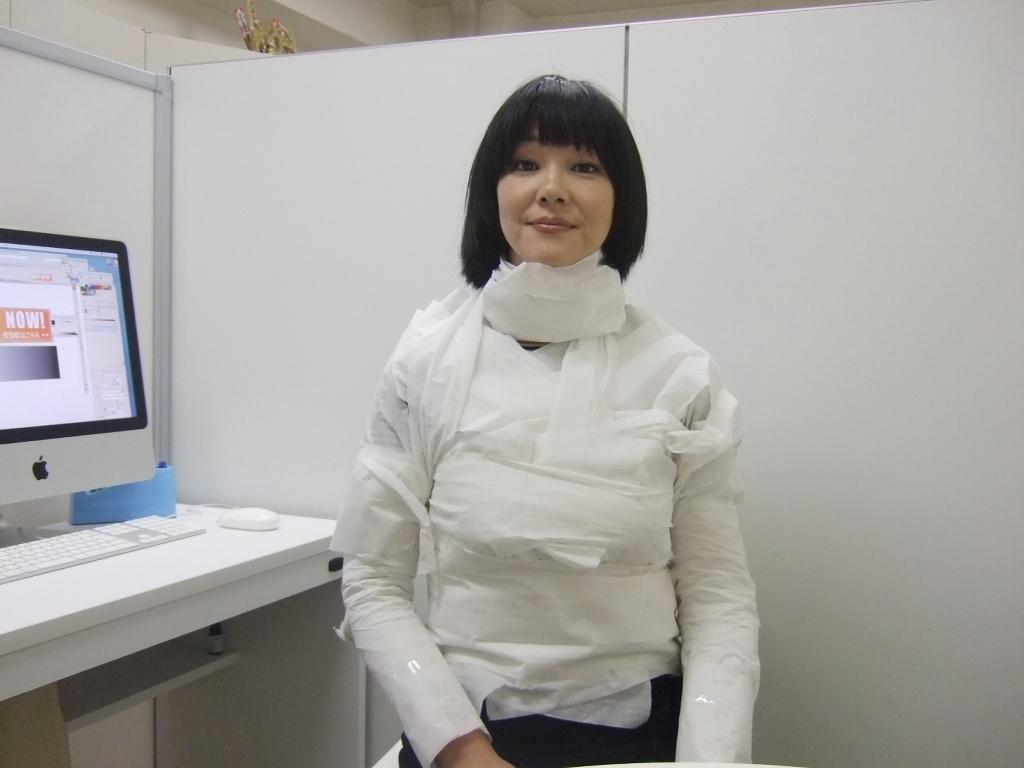Can you describe this image briefly? In this image in the foreground there is a woman having black hair and on the left side there is a system. 